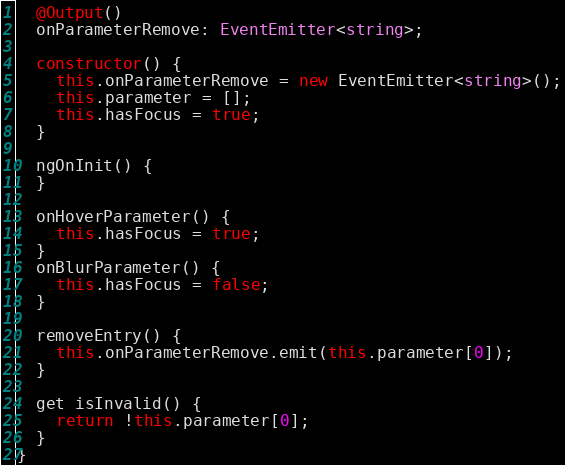Convert code to text. <code><loc_0><loc_0><loc_500><loc_500><_TypeScript_>  @Output()
  onParameterRemove: EventEmitter<string>;

  constructor() {
    this.onParameterRemove = new EventEmitter<string>();
    this.parameter = [];
    this.hasFocus = true;
  }

  ngOnInit() {
  }

  onHoverParameter() {
    this.hasFocus = true;
  }
  onBlurParameter() {
    this.hasFocus = false;
  }

  removeEntry() {
    this.onParameterRemove.emit(this.parameter[0]);
  }

  get isInvalid() {
    return !this.parameter[0];
  }
}
</code> 